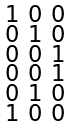Convert formula to latex. <formula><loc_0><loc_0><loc_500><loc_500>\begin{smallmatrix} 1 & 0 & 0 \\ 0 & 1 & 0 \\ 0 & 0 & 1 \\ 0 & 0 & 1 \\ 0 & 1 & 0 \\ 1 & 0 & 0 \end{smallmatrix}</formula> 